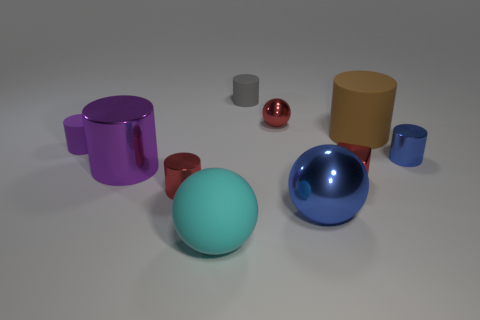Subtract 3 cylinders. How many cylinders are left? 3 Subtract all gray cylinders. How many cylinders are left? 5 Subtract all purple metallic cylinders. How many cylinders are left? 5 Subtract all cyan cylinders. Subtract all green cubes. How many cylinders are left? 6 Subtract all spheres. How many objects are left? 7 Add 8 red shiny balls. How many red shiny balls exist? 9 Subtract 0 green cylinders. How many objects are left? 10 Subtract all gray objects. Subtract all purple matte things. How many objects are left? 8 Add 2 large metallic balls. How many large metallic balls are left? 3 